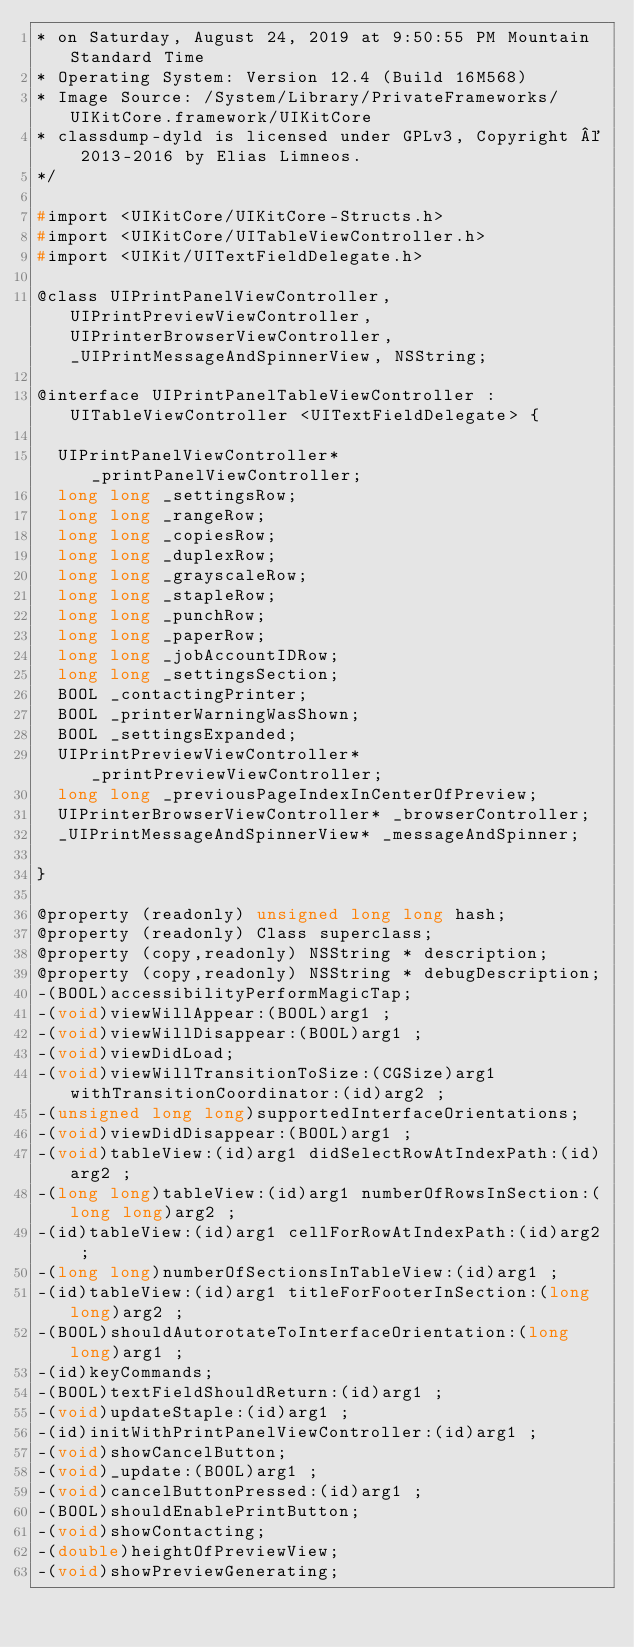Convert code to text. <code><loc_0><loc_0><loc_500><loc_500><_C_>* on Saturday, August 24, 2019 at 9:50:55 PM Mountain Standard Time
* Operating System: Version 12.4 (Build 16M568)
* Image Source: /System/Library/PrivateFrameworks/UIKitCore.framework/UIKitCore
* classdump-dyld is licensed under GPLv3, Copyright © 2013-2016 by Elias Limneos.
*/

#import <UIKitCore/UIKitCore-Structs.h>
#import <UIKitCore/UITableViewController.h>
#import <UIKit/UITextFieldDelegate.h>

@class UIPrintPanelViewController, UIPrintPreviewViewController, UIPrinterBrowserViewController, _UIPrintMessageAndSpinnerView, NSString;

@interface UIPrintPanelTableViewController : UITableViewController <UITextFieldDelegate> {

	UIPrintPanelViewController* _printPanelViewController;
	long long _settingsRow;
	long long _rangeRow;
	long long _copiesRow;
	long long _duplexRow;
	long long _grayscaleRow;
	long long _stapleRow;
	long long _punchRow;
	long long _paperRow;
	long long _jobAccountIDRow;
	long long _settingsSection;
	BOOL _contactingPrinter;
	BOOL _printerWarningWasShown;
	BOOL _settingsExpanded;
	UIPrintPreviewViewController* _printPreviewViewController;
	long long _previousPageIndexInCenterOfPreview;
	UIPrinterBrowserViewController* _browserController;
	_UIPrintMessageAndSpinnerView* _messageAndSpinner;

}

@property (readonly) unsigned long long hash; 
@property (readonly) Class superclass; 
@property (copy,readonly) NSString * description; 
@property (copy,readonly) NSString * debugDescription; 
-(BOOL)accessibilityPerformMagicTap;
-(void)viewWillAppear:(BOOL)arg1 ;
-(void)viewWillDisappear:(BOOL)arg1 ;
-(void)viewDidLoad;
-(void)viewWillTransitionToSize:(CGSize)arg1 withTransitionCoordinator:(id)arg2 ;
-(unsigned long long)supportedInterfaceOrientations;
-(void)viewDidDisappear:(BOOL)arg1 ;
-(void)tableView:(id)arg1 didSelectRowAtIndexPath:(id)arg2 ;
-(long long)tableView:(id)arg1 numberOfRowsInSection:(long long)arg2 ;
-(id)tableView:(id)arg1 cellForRowAtIndexPath:(id)arg2 ;
-(long long)numberOfSectionsInTableView:(id)arg1 ;
-(id)tableView:(id)arg1 titleForFooterInSection:(long long)arg2 ;
-(BOOL)shouldAutorotateToInterfaceOrientation:(long long)arg1 ;
-(id)keyCommands;
-(BOOL)textFieldShouldReturn:(id)arg1 ;
-(void)updateStaple:(id)arg1 ;
-(id)initWithPrintPanelViewController:(id)arg1 ;
-(void)showCancelButton;
-(void)_update:(BOOL)arg1 ;
-(void)cancelButtonPressed:(id)arg1 ;
-(BOOL)shouldEnablePrintButton;
-(void)showContacting;
-(double)heightOfPreviewView;
-(void)showPreviewGenerating;</code> 